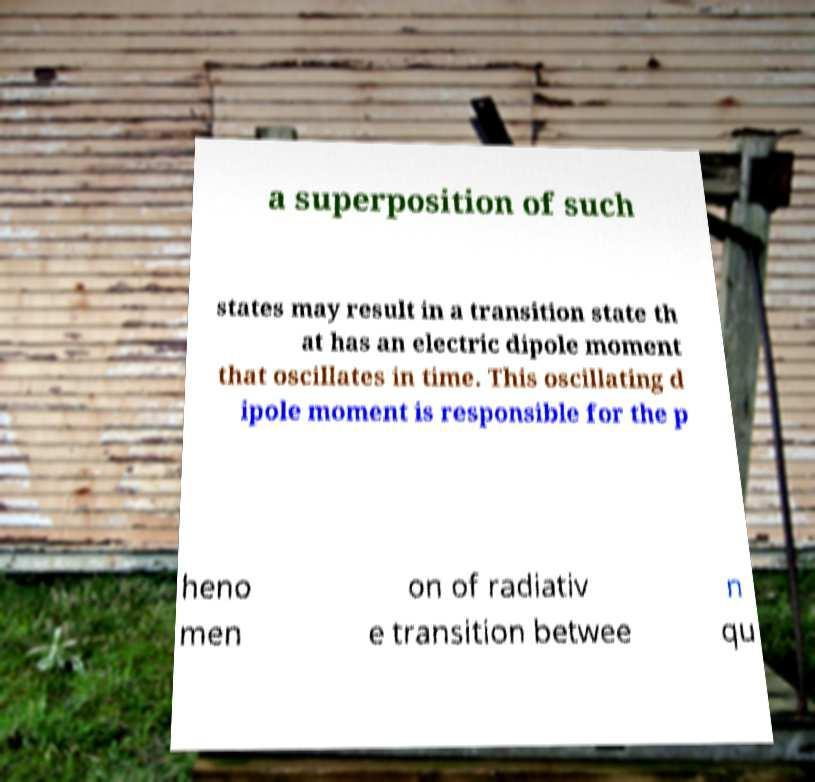What messages or text are displayed in this image? I need them in a readable, typed format. a superposition of such states may result in a transition state th at has an electric dipole moment that oscillates in time. This oscillating d ipole moment is responsible for the p heno men on of radiativ e transition betwee n qu 